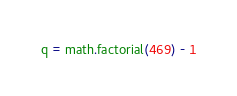<code> <loc_0><loc_0><loc_500><loc_500><_Python_>q = math.factorial(469) - 1
</code> 